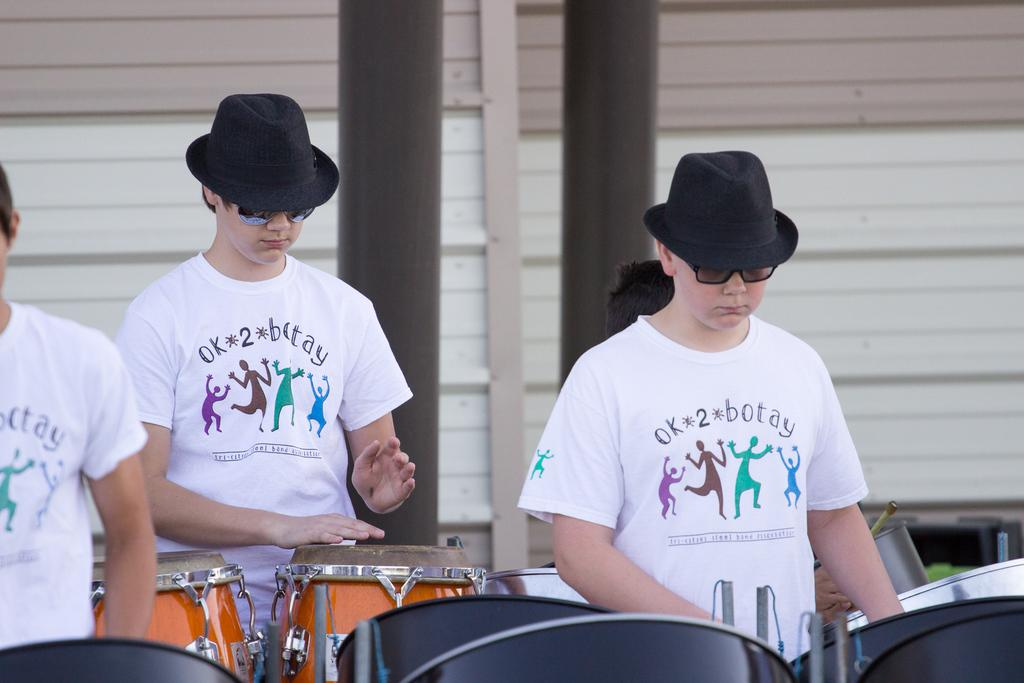How many people are in the image? There are three people in the image. What are the people doing in the image? The three people are standing and beating drums. What color shirts are two of the people wearing? Two of the people are wearing white color shirts. What type of goose is leading the group in the image? There is no goose present in the image; it features three people beating drums. Who is driving the vehicle in the image? There is no vehicle present in the image, so no one is driving. 